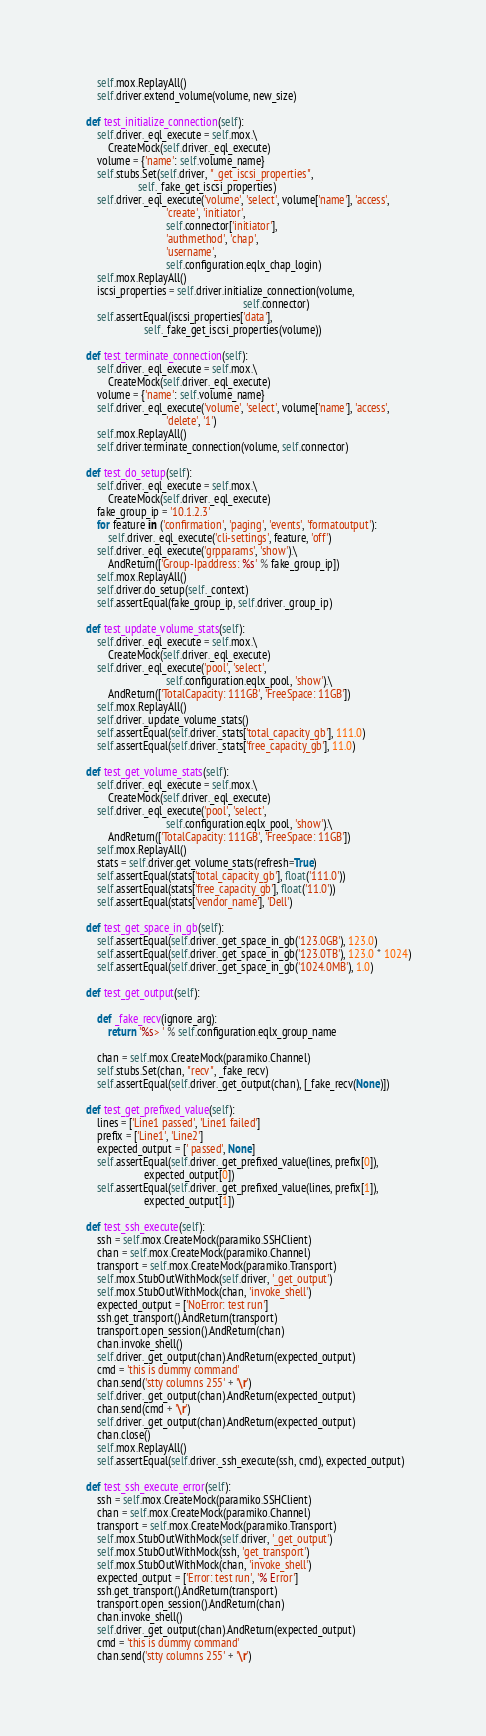<code> <loc_0><loc_0><loc_500><loc_500><_Python_>        self.mox.ReplayAll()
        self.driver.extend_volume(volume, new_size)

    def test_initialize_connection(self):
        self.driver._eql_execute = self.mox.\
            CreateMock(self.driver._eql_execute)
        volume = {'name': self.volume_name}
        self.stubs.Set(self.driver, "_get_iscsi_properties",
                       self._fake_get_iscsi_properties)
        self.driver._eql_execute('volume', 'select', volume['name'], 'access',
                                 'create', 'initiator',
                                 self.connector['initiator'],
                                 'authmethod', 'chap',
                                 'username',
                                 self.configuration.eqlx_chap_login)
        self.mox.ReplayAll()
        iscsi_properties = self.driver.initialize_connection(volume,
                                                             self.connector)
        self.assertEqual(iscsi_properties['data'],
                         self._fake_get_iscsi_properties(volume))

    def test_terminate_connection(self):
        self.driver._eql_execute = self.mox.\
            CreateMock(self.driver._eql_execute)
        volume = {'name': self.volume_name}
        self.driver._eql_execute('volume', 'select', volume['name'], 'access',
                                 'delete', '1')
        self.mox.ReplayAll()
        self.driver.terminate_connection(volume, self.connector)

    def test_do_setup(self):
        self.driver._eql_execute = self.mox.\
            CreateMock(self.driver._eql_execute)
        fake_group_ip = '10.1.2.3'
        for feature in ('confirmation', 'paging', 'events', 'formatoutput'):
            self.driver._eql_execute('cli-settings', feature, 'off')
        self.driver._eql_execute('grpparams', 'show').\
            AndReturn(['Group-Ipaddress: %s' % fake_group_ip])
        self.mox.ReplayAll()
        self.driver.do_setup(self._context)
        self.assertEqual(fake_group_ip, self.driver._group_ip)

    def test_update_volume_stats(self):
        self.driver._eql_execute = self.mox.\
            CreateMock(self.driver._eql_execute)
        self.driver._eql_execute('pool', 'select',
                                 self.configuration.eqlx_pool, 'show').\
            AndReturn(['TotalCapacity: 111GB', 'FreeSpace: 11GB'])
        self.mox.ReplayAll()
        self.driver._update_volume_stats()
        self.assertEqual(self.driver._stats['total_capacity_gb'], 111.0)
        self.assertEqual(self.driver._stats['free_capacity_gb'], 11.0)

    def test_get_volume_stats(self):
        self.driver._eql_execute = self.mox.\
            CreateMock(self.driver._eql_execute)
        self.driver._eql_execute('pool', 'select',
                                 self.configuration.eqlx_pool, 'show').\
            AndReturn(['TotalCapacity: 111GB', 'FreeSpace: 11GB'])
        self.mox.ReplayAll()
        stats = self.driver.get_volume_stats(refresh=True)
        self.assertEqual(stats['total_capacity_gb'], float('111.0'))
        self.assertEqual(stats['free_capacity_gb'], float('11.0'))
        self.assertEqual(stats['vendor_name'], 'Dell')

    def test_get_space_in_gb(self):
        self.assertEqual(self.driver._get_space_in_gb('123.0GB'), 123.0)
        self.assertEqual(self.driver._get_space_in_gb('123.0TB'), 123.0 * 1024)
        self.assertEqual(self.driver._get_space_in_gb('1024.0MB'), 1.0)

    def test_get_output(self):

        def _fake_recv(ignore_arg):
            return '%s> ' % self.configuration.eqlx_group_name

        chan = self.mox.CreateMock(paramiko.Channel)
        self.stubs.Set(chan, "recv", _fake_recv)
        self.assertEqual(self.driver._get_output(chan), [_fake_recv(None)])

    def test_get_prefixed_value(self):
        lines = ['Line1 passed', 'Line1 failed']
        prefix = ['Line1', 'Line2']
        expected_output = [' passed', None]
        self.assertEqual(self.driver._get_prefixed_value(lines, prefix[0]),
                         expected_output[0])
        self.assertEqual(self.driver._get_prefixed_value(lines, prefix[1]),
                         expected_output[1])

    def test_ssh_execute(self):
        ssh = self.mox.CreateMock(paramiko.SSHClient)
        chan = self.mox.CreateMock(paramiko.Channel)
        transport = self.mox.CreateMock(paramiko.Transport)
        self.mox.StubOutWithMock(self.driver, '_get_output')
        self.mox.StubOutWithMock(chan, 'invoke_shell')
        expected_output = ['NoError: test run']
        ssh.get_transport().AndReturn(transport)
        transport.open_session().AndReturn(chan)
        chan.invoke_shell()
        self.driver._get_output(chan).AndReturn(expected_output)
        cmd = 'this is dummy command'
        chan.send('stty columns 255' + '\r')
        self.driver._get_output(chan).AndReturn(expected_output)
        chan.send(cmd + '\r')
        self.driver._get_output(chan).AndReturn(expected_output)
        chan.close()
        self.mox.ReplayAll()
        self.assertEqual(self.driver._ssh_execute(ssh, cmd), expected_output)

    def test_ssh_execute_error(self):
        ssh = self.mox.CreateMock(paramiko.SSHClient)
        chan = self.mox.CreateMock(paramiko.Channel)
        transport = self.mox.CreateMock(paramiko.Transport)
        self.mox.StubOutWithMock(self.driver, '_get_output')
        self.mox.StubOutWithMock(ssh, 'get_transport')
        self.mox.StubOutWithMock(chan, 'invoke_shell')
        expected_output = ['Error: test run', '% Error']
        ssh.get_transport().AndReturn(transport)
        transport.open_session().AndReturn(chan)
        chan.invoke_shell()
        self.driver._get_output(chan).AndReturn(expected_output)
        cmd = 'this is dummy command'
        chan.send('stty columns 255' + '\r')</code> 